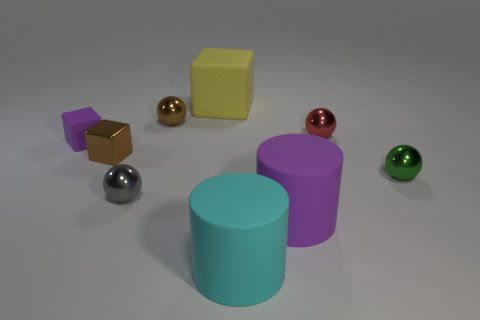What shape is the purple rubber object that is on the left side of the big cyan object? cube 